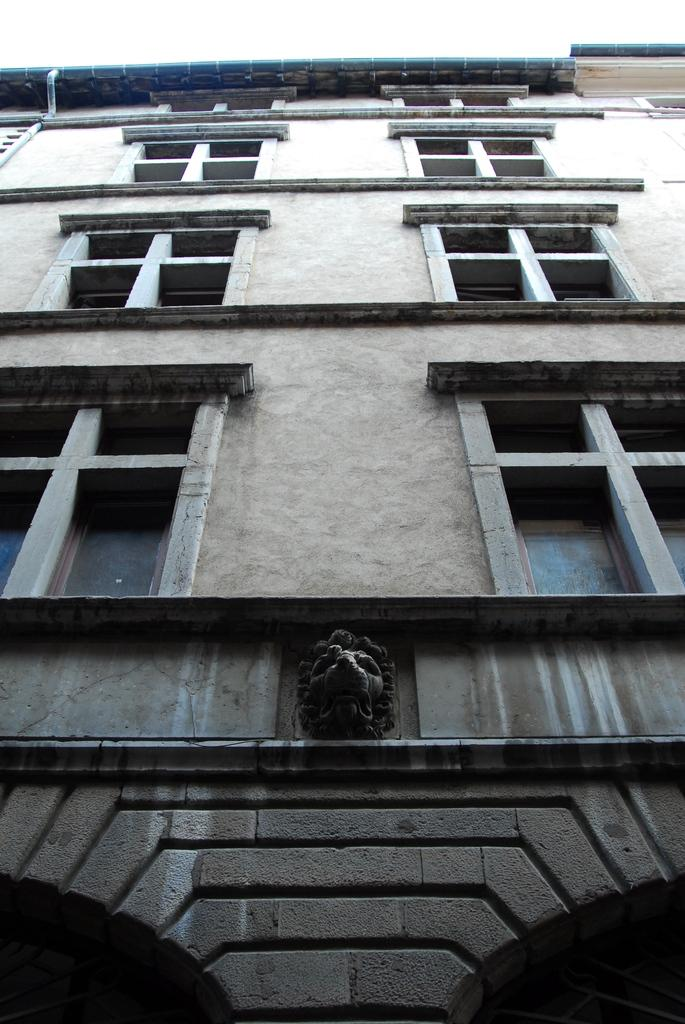What type of structure is present in the image? There is a building in the image. Are there any other objects or features in the image besides the building? Yes, there is a statue in the image. What can be seen on the building in the image? Windows are visible in the image. What type of tank is visible in the image? There is no tank present in the image. How many matches are being used to light the statue in the image? There are no matches or any indication of lighting in the image; it only features a building and a statue. 